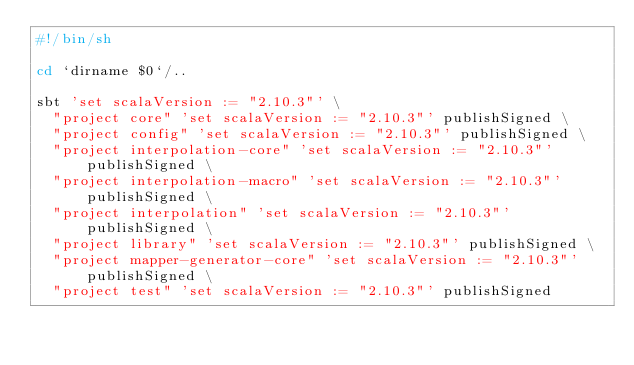<code> <loc_0><loc_0><loc_500><loc_500><_Bash_>#!/bin/sh

cd `dirname $0`/..

sbt 'set scalaVersion := "2.10.3"' \
  "project core" 'set scalaVersion := "2.10.3"' publishSigned \
  "project config" 'set scalaVersion := "2.10.3"' publishSigned \
  "project interpolation-core" 'set scalaVersion := "2.10.3"' publishSigned \
  "project interpolation-macro" 'set scalaVersion := "2.10.3"' publishSigned \
  "project interpolation" 'set scalaVersion := "2.10.3"' publishSigned \
  "project library" 'set scalaVersion := "2.10.3"' publishSigned \
  "project mapper-generator-core" 'set scalaVersion := "2.10.3"' publishSigned \
  "project test" 'set scalaVersion := "2.10.3"' publishSigned 

</code> 